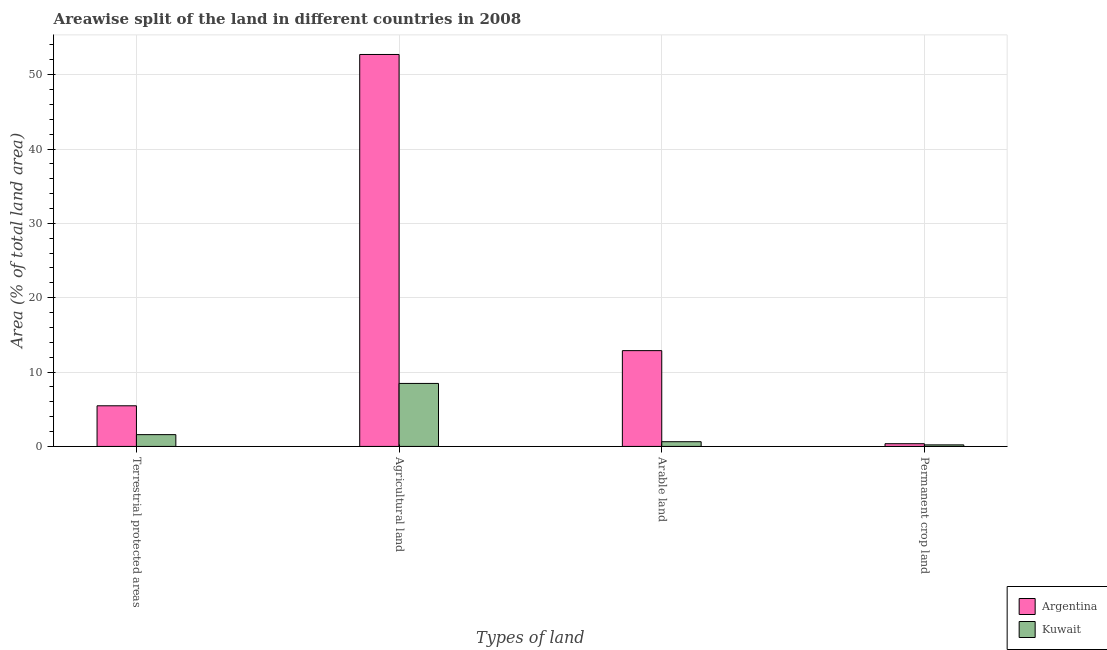How many different coloured bars are there?
Provide a succinct answer. 2. How many groups of bars are there?
Keep it short and to the point. 4. Are the number of bars per tick equal to the number of legend labels?
Offer a terse response. Yes. What is the label of the 2nd group of bars from the left?
Make the answer very short. Agricultural land. What is the percentage of area under agricultural land in Kuwait?
Ensure brevity in your answer.  8.47. Across all countries, what is the maximum percentage of area under permanent crop land?
Keep it short and to the point. 0.37. Across all countries, what is the minimum percentage of area under agricultural land?
Your answer should be very brief. 8.47. In which country was the percentage of land under terrestrial protection maximum?
Ensure brevity in your answer.  Argentina. In which country was the percentage of area under agricultural land minimum?
Offer a terse response. Kuwait. What is the total percentage of area under agricultural land in the graph?
Offer a terse response. 61.19. What is the difference between the percentage of land under terrestrial protection in Kuwait and that in Argentina?
Your answer should be very brief. -3.88. What is the difference between the percentage of area under permanent crop land in Argentina and the percentage of area under agricultural land in Kuwait?
Your answer should be compact. -8.11. What is the average percentage of area under agricultural land per country?
Provide a short and direct response. 30.59. What is the difference between the percentage of land under terrestrial protection and percentage of area under permanent crop land in Kuwait?
Give a very brief answer. 1.38. In how many countries, is the percentage of area under agricultural land greater than 18 %?
Give a very brief answer. 1. What is the ratio of the percentage of area under permanent crop land in Argentina to that in Kuwait?
Provide a succinct answer. 1.76. What is the difference between the highest and the second highest percentage of land under terrestrial protection?
Give a very brief answer. 3.88. What is the difference between the highest and the lowest percentage of area under permanent crop land?
Give a very brief answer. 0.16. In how many countries, is the percentage of area under agricultural land greater than the average percentage of area under agricultural land taken over all countries?
Give a very brief answer. 1. Is the sum of the percentage of area under permanent crop land in Kuwait and Argentina greater than the maximum percentage of area under arable land across all countries?
Provide a short and direct response. No. Is it the case that in every country, the sum of the percentage of land under terrestrial protection and percentage of area under permanent crop land is greater than the sum of percentage of area under arable land and percentage of area under agricultural land?
Keep it short and to the point. No. What does the 2nd bar from the left in Terrestrial protected areas represents?
Keep it short and to the point. Kuwait. What does the 1st bar from the right in Arable land represents?
Your response must be concise. Kuwait. Is it the case that in every country, the sum of the percentage of land under terrestrial protection and percentage of area under agricultural land is greater than the percentage of area under arable land?
Your response must be concise. Yes. How many bars are there?
Provide a succinct answer. 8. Are all the bars in the graph horizontal?
Keep it short and to the point. No. How many countries are there in the graph?
Keep it short and to the point. 2. Does the graph contain any zero values?
Ensure brevity in your answer.  No. How many legend labels are there?
Ensure brevity in your answer.  2. What is the title of the graph?
Give a very brief answer. Areawise split of the land in different countries in 2008. Does "Philippines" appear as one of the legend labels in the graph?
Provide a succinct answer. No. What is the label or title of the X-axis?
Give a very brief answer. Types of land. What is the label or title of the Y-axis?
Offer a very short reply. Area (% of total land area). What is the Area (% of total land area) of Argentina in Terrestrial protected areas?
Offer a very short reply. 5.47. What is the Area (% of total land area) in Kuwait in Terrestrial protected areas?
Your answer should be very brief. 1.59. What is the Area (% of total land area) of Argentina in Agricultural land?
Your answer should be very brief. 52.71. What is the Area (% of total land area) of Kuwait in Agricultural land?
Keep it short and to the point. 8.47. What is the Area (% of total land area) in Argentina in Arable land?
Make the answer very short. 12.88. What is the Area (% of total land area) in Kuwait in Arable land?
Ensure brevity in your answer.  0.63. What is the Area (% of total land area) in Argentina in Permanent crop land?
Make the answer very short. 0.37. What is the Area (% of total land area) of Kuwait in Permanent crop land?
Make the answer very short. 0.21. Across all Types of land, what is the maximum Area (% of total land area) of Argentina?
Offer a very short reply. 52.71. Across all Types of land, what is the maximum Area (% of total land area) of Kuwait?
Provide a succinct answer. 8.47. Across all Types of land, what is the minimum Area (% of total land area) of Argentina?
Ensure brevity in your answer.  0.37. Across all Types of land, what is the minimum Area (% of total land area) of Kuwait?
Make the answer very short. 0.21. What is the total Area (% of total land area) in Argentina in the graph?
Offer a very short reply. 71.43. What is the total Area (% of total land area) of Kuwait in the graph?
Provide a short and direct response. 10.9. What is the difference between the Area (% of total land area) in Argentina in Terrestrial protected areas and that in Agricultural land?
Offer a very short reply. -47.25. What is the difference between the Area (% of total land area) in Kuwait in Terrestrial protected areas and that in Agricultural land?
Give a very brief answer. -6.89. What is the difference between the Area (% of total land area) in Argentina in Terrestrial protected areas and that in Arable land?
Your answer should be compact. -7.42. What is the difference between the Area (% of total land area) of Kuwait in Terrestrial protected areas and that in Arable land?
Ensure brevity in your answer.  0.95. What is the difference between the Area (% of total land area) of Argentina in Terrestrial protected areas and that in Permanent crop land?
Your answer should be compact. 5.1. What is the difference between the Area (% of total land area) of Kuwait in Terrestrial protected areas and that in Permanent crop land?
Provide a short and direct response. 1.38. What is the difference between the Area (% of total land area) of Argentina in Agricultural land and that in Arable land?
Provide a short and direct response. 39.83. What is the difference between the Area (% of total land area) of Kuwait in Agricultural land and that in Arable land?
Your answer should be very brief. 7.84. What is the difference between the Area (% of total land area) in Argentina in Agricultural land and that in Permanent crop land?
Make the answer very short. 52.35. What is the difference between the Area (% of total land area) of Kuwait in Agricultural land and that in Permanent crop land?
Offer a terse response. 8.27. What is the difference between the Area (% of total land area) of Argentina in Arable land and that in Permanent crop land?
Provide a short and direct response. 12.52. What is the difference between the Area (% of total land area) of Kuwait in Arable land and that in Permanent crop land?
Provide a succinct answer. 0.43. What is the difference between the Area (% of total land area) in Argentina in Terrestrial protected areas and the Area (% of total land area) in Kuwait in Agricultural land?
Offer a terse response. -3.01. What is the difference between the Area (% of total land area) of Argentina in Terrestrial protected areas and the Area (% of total land area) of Kuwait in Arable land?
Offer a very short reply. 4.83. What is the difference between the Area (% of total land area) of Argentina in Terrestrial protected areas and the Area (% of total land area) of Kuwait in Permanent crop land?
Provide a succinct answer. 5.26. What is the difference between the Area (% of total land area) in Argentina in Agricultural land and the Area (% of total land area) in Kuwait in Arable land?
Make the answer very short. 52.08. What is the difference between the Area (% of total land area) in Argentina in Agricultural land and the Area (% of total land area) in Kuwait in Permanent crop land?
Offer a terse response. 52.51. What is the difference between the Area (% of total land area) of Argentina in Arable land and the Area (% of total land area) of Kuwait in Permanent crop land?
Offer a terse response. 12.68. What is the average Area (% of total land area) in Argentina per Types of land?
Your answer should be very brief. 17.86. What is the average Area (% of total land area) in Kuwait per Types of land?
Make the answer very short. 2.73. What is the difference between the Area (% of total land area) of Argentina and Area (% of total land area) of Kuwait in Terrestrial protected areas?
Your response must be concise. 3.88. What is the difference between the Area (% of total land area) in Argentina and Area (% of total land area) in Kuwait in Agricultural land?
Provide a short and direct response. 44.24. What is the difference between the Area (% of total land area) of Argentina and Area (% of total land area) of Kuwait in Arable land?
Give a very brief answer. 12.25. What is the difference between the Area (% of total land area) in Argentina and Area (% of total land area) in Kuwait in Permanent crop land?
Your answer should be compact. 0.16. What is the ratio of the Area (% of total land area) of Argentina in Terrestrial protected areas to that in Agricultural land?
Your response must be concise. 0.1. What is the ratio of the Area (% of total land area) in Kuwait in Terrestrial protected areas to that in Agricultural land?
Ensure brevity in your answer.  0.19. What is the ratio of the Area (% of total land area) in Argentina in Terrestrial protected areas to that in Arable land?
Ensure brevity in your answer.  0.42. What is the ratio of the Area (% of total land area) of Kuwait in Terrestrial protected areas to that in Arable land?
Offer a terse response. 2.5. What is the ratio of the Area (% of total land area) in Argentina in Terrestrial protected areas to that in Permanent crop land?
Keep it short and to the point. 14.96. What is the ratio of the Area (% of total land area) in Kuwait in Terrestrial protected areas to that in Permanent crop land?
Offer a terse response. 7.64. What is the ratio of the Area (% of total land area) in Argentina in Agricultural land to that in Arable land?
Give a very brief answer. 4.09. What is the ratio of the Area (% of total land area) of Kuwait in Agricultural land to that in Arable land?
Your response must be concise. 13.36. What is the ratio of the Area (% of total land area) in Argentina in Agricultural land to that in Permanent crop land?
Provide a short and direct response. 144.26. What is the ratio of the Area (% of total land area) in Kuwait in Agricultural land to that in Permanent crop land?
Make the answer very short. 40.81. What is the ratio of the Area (% of total land area) of Argentina in Arable land to that in Permanent crop land?
Provide a succinct answer. 35.26. What is the ratio of the Area (% of total land area) in Kuwait in Arable land to that in Permanent crop land?
Give a very brief answer. 3.05. What is the difference between the highest and the second highest Area (% of total land area) in Argentina?
Your answer should be very brief. 39.83. What is the difference between the highest and the second highest Area (% of total land area) of Kuwait?
Make the answer very short. 6.89. What is the difference between the highest and the lowest Area (% of total land area) in Argentina?
Give a very brief answer. 52.35. What is the difference between the highest and the lowest Area (% of total land area) in Kuwait?
Offer a very short reply. 8.27. 